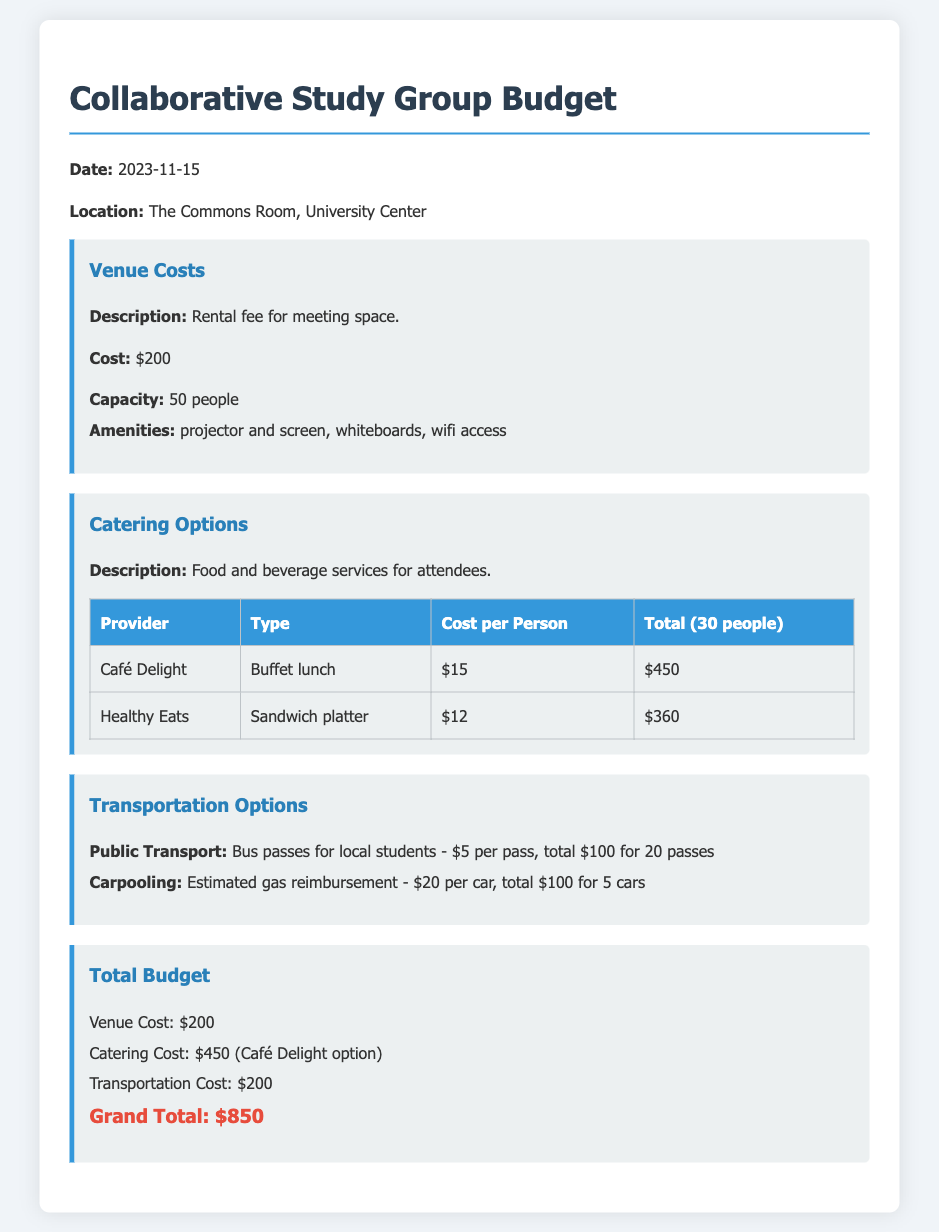What is the date of the event? The date of the event is mentioned in the document as a specific date, which is 2023-11-15.
Answer: 2023-11-15 What is the venue cost? The venue cost is listed clearly in the budget section, which is $200.
Answer: $200 How many people can the venue accommodate? The document states that the venue has a capacity for 50 people.
Answer: 50 people What is the total catering cost for Café Delight option? The document provides a specific total for catering using the Café Delight option, which is $450.
Answer: $450 How much is the transportation cost for public transport? The budget outlines the cost for public transport as $100 for 20 passes.
Answer: $100 What is the grand total budget for the event? The grand total budget is summarized in the document as the final total, which is $850.
Answer: $850 Which catering provider offers a sandwich platter? The document lists Healthy Eats as the provider offering a sandwich platter.
Answer: Healthy Eats How many cars are estimated for carpooling? The document mentions a total of 5 cars estimated for carpooling.
Answer: 5 cars What amenities does the venue provide? Amenities are explicitly listed in the document, which includes projector and screen, whiteboards, and wifi access.
Answer: projector and screen, whiteboards, wifi access 